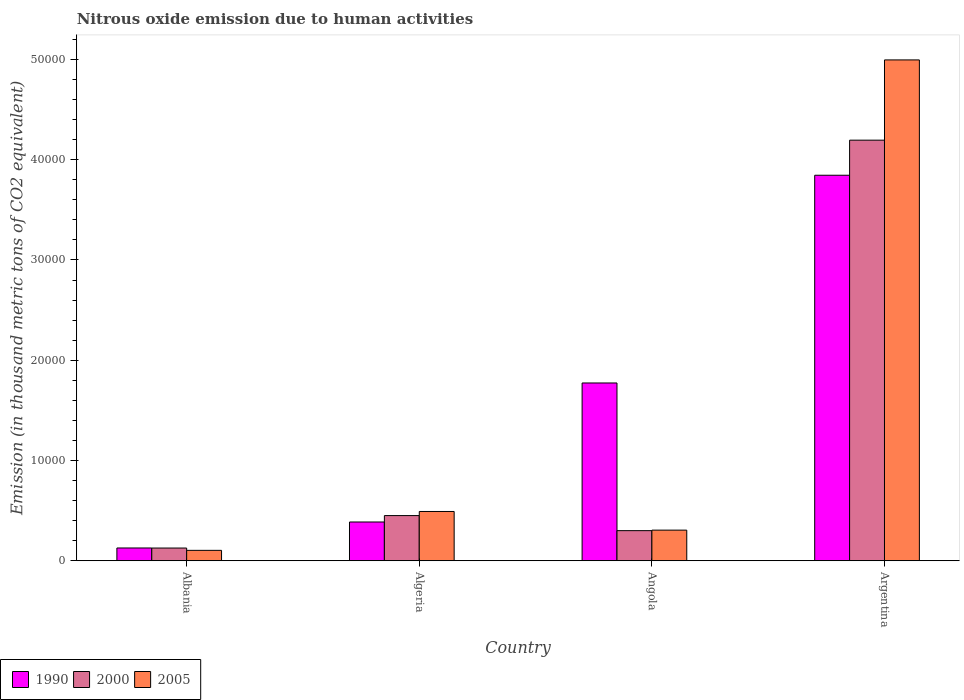How many groups of bars are there?
Your answer should be very brief. 4. What is the label of the 1st group of bars from the left?
Your response must be concise. Albania. In how many cases, is the number of bars for a given country not equal to the number of legend labels?
Make the answer very short. 0. What is the amount of nitrous oxide emitted in 2005 in Algeria?
Make the answer very short. 4917. Across all countries, what is the maximum amount of nitrous oxide emitted in 1990?
Your answer should be compact. 3.85e+04. Across all countries, what is the minimum amount of nitrous oxide emitted in 2005?
Ensure brevity in your answer.  1039.6. In which country was the amount of nitrous oxide emitted in 2005 minimum?
Give a very brief answer. Albania. What is the total amount of nitrous oxide emitted in 1990 in the graph?
Offer a terse response. 6.13e+04. What is the difference between the amount of nitrous oxide emitted in 2005 in Algeria and that in Argentina?
Your response must be concise. -4.50e+04. What is the difference between the amount of nitrous oxide emitted in 2005 in Argentina and the amount of nitrous oxide emitted in 1990 in Angola?
Provide a short and direct response. 3.22e+04. What is the average amount of nitrous oxide emitted in 2005 per country?
Your answer should be very brief. 1.47e+04. What is the difference between the amount of nitrous oxide emitted of/in 2005 and amount of nitrous oxide emitted of/in 2000 in Algeria?
Offer a terse response. 409.9. In how many countries, is the amount of nitrous oxide emitted in 2005 greater than 42000 thousand metric tons?
Make the answer very short. 1. What is the ratio of the amount of nitrous oxide emitted in 1990 in Angola to that in Argentina?
Offer a terse response. 0.46. What is the difference between the highest and the second highest amount of nitrous oxide emitted in 1990?
Offer a very short reply. -3.46e+04. What is the difference between the highest and the lowest amount of nitrous oxide emitted in 2005?
Your response must be concise. 4.89e+04. In how many countries, is the amount of nitrous oxide emitted in 2000 greater than the average amount of nitrous oxide emitted in 2000 taken over all countries?
Ensure brevity in your answer.  1. What does the 2nd bar from the left in Argentina represents?
Provide a short and direct response. 2000. What does the 1st bar from the right in Albania represents?
Your response must be concise. 2005. Is it the case that in every country, the sum of the amount of nitrous oxide emitted in 2005 and amount of nitrous oxide emitted in 1990 is greater than the amount of nitrous oxide emitted in 2000?
Your response must be concise. Yes. Are the values on the major ticks of Y-axis written in scientific E-notation?
Offer a terse response. No. Does the graph contain any zero values?
Make the answer very short. No. What is the title of the graph?
Your response must be concise. Nitrous oxide emission due to human activities. What is the label or title of the Y-axis?
Provide a short and direct response. Emission (in thousand metric tons of CO2 equivalent). What is the Emission (in thousand metric tons of CO2 equivalent) of 1990 in Albania?
Provide a short and direct response. 1276.4. What is the Emission (in thousand metric tons of CO2 equivalent) in 2000 in Albania?
Your answer should be very brief. 1270.7. What is the Emission (in thousand metric tons of CO2 equivalent) of 2005 in Albania?
Your answer should be compact. 1039.6. What is the Emission (in thousand metric tons of CO2 equivalent) of 1990 in Algeria?
Offer a terse response. 3867.6. What is the Emission (in thousand metric tons of CO2 equivalent) of 2000 in Algeria?
Your answer should be compact. 4507.1. What is the Emission (in thousand metric tons of CO2 equivalent) in 2005 in Algeria?
Give a very brief answer. 4917. What is the Emission (in thousand metric tons of CO2 equivalent) in 1990 in Angola?
Your answer should be compact. 1.77e+04. What is the Emission (in thousand metric tons of CO2 equivalent) of 2000 in Angola?
Keep it short and to the point. 3005.3. What is the Emission (in thousand metric tons of CO2 equivalent) in 2005 in Angola?
Your response must be concise. 3056.7. What is the Emission (in thousand metric tons of CO2 equivalent) in 1990 in Argentina?
Give a very brief answer. 3.85e+04. What is the Emission (in thousand metric tons of CO2 equivalent) in 2000 in Argentina?
Keep it short and to the point. 4.20e+04. What is the Emission (in thousand metric tons of CO2 equivalent) of 2005 in Argentina?
Your response must be concise. 5.00e+04. Across all countries, what is the maximum Emission (in thousand metric tons of CO2 equivalent) in 1990?
Provide a short and direct response. 3.85e+04. Across all countries, what is the maximum Emission (in thousand metric tons of CO2 equivalent) of 2000?
Ensure brevity in your answer.  4.20e+04. Across all countries, what is the maximum Emission (in thousand metric tons of CO2 equivalent) in 2005?
Give a very brief answer. 5.00e+04. Across all countries, what is the minimum Emission (in thousand metric tons of CO2 equivalent) of 1990?
Ensure brevity in your answer.  1276.4. Across all countries, what is the minimum Emission (in thousand metric tons of CO2 equivalent) in 2000?
Offer a terse response. 1270.7. Across all countries, what is the minimum Emission (in thousand metric tons of CO2 equivalent) in 2005?
Offer a terse response. 1039.6. What is the total Emission (in thousand metric tons of CO2 equivalent) of 1990 in the graph?
Ensure brevity in your answer.  6.13e+04. What is the total Emission (in thousand metric tons of CO2 equivalent) in 2000 in the graph?
Your answer should be very brief. 5.07e+04. What is the total Emission (in thousand metric tons of CO2 equivalent) of 2005 in the graph?
Ensure brevity in your answer.  5.90e+04. What is the difference between the Emission (in thousand metric tons of CO2 equivalent) in 1990 in Albania and that in Algeria?
Your answer should be compact. -2591.2. What is the difference between the Emission (in thousand metric tons of CO2 equivalent) of 2000 in Albania and that in Algeria?
Make the answer very short. -3236.4. What is the difference between the Emission (in thousand metric tons of CO2 equivalent) in 2005 in Albania and that in Algeria?
Your answer should be compact. -3877.4. What is the difference between the Emission (in thousand metric tons of CO2 equivalent) in 1990 in Albania and that in Angola?
Offer a very short reply. -1.65e+04. What is the difference between the Emission (in thousand metric tons of CO2 equivalent) of 2000 in Albania and that in Angola?
Offer a very short reply. -1734.6. What is the difference between the Emission (in thousand metric tons of CO2 equivalent) in 2005 in Albania and that in Angola?
Provide a short and direct response. -2017.1. What is the difference between the Emission (in thousand metric tons of CO2 equivalent) in 1990 in Albania and that in Argentina?
Make the answer very short. -3.72e+04. What is the difference between the Emission (in thousand metric tons of CO2 equivalent) of 2000 in Albania and that in Argentina?
Provide a succinct answer. -4.07e+04. What is the difference between the Emission (in thousand metric tons of CO2 equivalent) in 2005 in Albania and that in Argentina?
Offer a terse response. -4.89e+04. What is the difference between the Emission (in thousand metric tons of CO2 equivalent) in 1990 in Algeria and that in Angola?
Offer a terse response. -1.39e+04. What is the difference between the Emission (in thousand metric tons of CO2 equivalent) in 2000 in Algeria and that in Angola?
Your answer should be very brief. 1501.8. What is the difference between the Emission (in thousand metric tons of CO2 equivalent) in 2005 in Algeria and that in Angola?
Your answer should be very brief. 1860.3. What is the difference between the Emission (in thousand metric tons of CO2 equivalent) of 1990 in Algeria and that in Argentina?
Your answer should be very brief. -3.46e+04. What is the difference between the Emission (in thousand metric tons of CO2 equivalent) of 2000 in Algeria and that in Argentina?
Give a very brief answer. -3.74e+04. What is the difference between the Emission (in thousand metric tons of CO2 equivalent) of 2005 in Algeria and that in Argentina?
Your response must be concise. -4.50e+04. What is the difference between the Emission (in thousand metric tons of CO2 equivalent) of 1990 in Angola and that in Argentina?
Your answer should be compact. -2.07e+04. What is the difference between the Emission (in thousand metric tons of CO2 equivalent) in 2000 in Angola and that in Argentina?
Your response must be concise. -3.89e+04. What is the difference between the Emission (in thousand metric tons of CO2 equivalent) in 2005 in Angola and that in Argentina?
Your answer should be very brief. -4.69e+04. What is the difference between the Emission (in thousand metric tons of CO2 equivalent) in 1990 in Albania and the Emission (in thousand metric tons of CO2 equivalent) in 2000 in Algeria?
Provide a succinct answer. -3230.7. What is the difference between the Emission (in thousand metric tons of CO2 equivalent) of 1990 in Albania and the Emission (in thousand metric tons of CO2 equivalent) of 2005 in Algeria?
Your answer should be compact. -3640.6. What is the difference between the Emission (in thousand metric tons of CO2 equivalent) of 2000 in Albania and the Emission (in thousand metric tons of CO2 equivalent) of 2005 in Algeria?
Make the answer very short. -3646.3. What is the difference between the Emission (in thousand metric tons of CO2 equivalent) in 1990 in Albania and the Emission (in thousand metric tons of CO2 equivalent) in 2000 in Angola?
Your response must be concise. -1728.9. What is the difference between the Emission (in thousand metric tons of CO2 equivalent) of 1990 in Albania and the Emission (in thousand metric tons of CO2 equivalent) of 2005 in Angola?
Ensure brevity in your answer.  -1780.3. What is the difference between the Emission (in thousand metric tons of CO2 equivalent) in 2000 in Albania and the Emission (in thousand metric tons of CO2 equivalent) in 2005 in Angola?
Offer a very short reply. -1786. What is the difference between the Emission (in thousand metric tons of CO2 equivalent) of 1990 in Albania and the Emission (in thousand metric tons of CO2 equivalent) of 2000 in Argentina?
Your answer should be very brief. -4.07e+04. What is the difference between the Emission (in thousand metric tons of CO2 equivalent) of 1990 in Albania and the Emission (in thousand metric tons of CO2 equivalent) of 2005 in Argentina?
Ensure brevity in your answer.  -4.87e+04. What is the difference between the Emission (in thousand metric tons of CO2 equivalent) in 2000 in Albania and the Emission (in thousand metric tons of CO2 equivalent) in 2005 in Argentina?
Offer a very short reply. -4.87e+04. What is the difference between the Emission (in thousand metric tons of CO2 equivalent) in 1990 in Algeria and the Emission (in thousand metric tons of CO2 equivalent) in 2000 in Angola?
Make the answer very short. 862.3. What is the difference between the Emission (in thousand metric tons of CO2 equivalent) of 1990 in Algeria and the Emission (in thousand metric tons of CO2 equivalent) of 2005 in Angola?
Your answer should be compact. 810.9. What is the difference between the Emission (in thousand metric tons of CO2 equivalent) of 2000 in Algeria and the Emission (in thousand metric tons of CO2 equivalent) of 2005 in Angola?
Give a very brief answer. 1450.4. What is the difference between the Emission (in thousand metric tons of CO2 equivalent) of 1990 in Algeria and the Emission (in thousand metric tons of CO2 equivalent) of 2000 in Argentina?
Provide a succinct answer. -3.81e+04. What is the difference between the Emission (in thousand metric tons of CO2 equivalent) in 1990 in Algeria and the Emission (in thousand metric tons of CO2 equivalent) in 2005 in Argentina?
Offer a terse response. -4.61e+04. What is the difference between the Emission (in thousand metric tons of CO2 equivalent) in 2000 in Algeria and the Emission (in thousand metric tons of CO2 equivalent) in 2005 in Argentina?
Provide a succinct answer. -4.54e+04. What is the difference between the Emission (in thousand metric tons of CO2 equivalent) of 1990 in Angola and the Emission (in thousand metric tons of CO2 equivalent) of 2000 in Argentina?
Your answer should be very brief. -2.42e+04. What is the difference between the Emission (in thousand metric tons of CO2 equivalent) in 1990 in Angola and the Emission (in thousand metric tons of CO2 equivalent) in 2005 in Argentina?
Your answer should be very brief. -3.22e+04. What is the difference between the Emission (in thousand metric tons of CO2 equivalent) in 2000 in Angola and the Emission (in thousand metric tons of CO2 equivalent) in 2005 in Argentina?
Your answer should be compact. -4.70e+04. What is the average Emission (in thousand metric tons of CO2 equivalent) in 1990 per country?
Provide a short and direct response. 1.53e+04. What is the average Emission (in thousand metric tons of CO2 equivalent) in 2000 per country?
Your response must be concise. 1.27e+04. What is the average Emission (in thousand metric tons of CO2 equivalent) of 2005 per country?
Your answer should be compact. 1.47e+04. What is the difference between the Emission (in thousand metric tons of CO2 equivalent) in 1990 and Emission (in thousand metric tons of CO2 equivalent) in 2000 in Albania?
Your answer should be very brief. 5.7. What is the difference between the Emission (in thousand metric tons of CO2 equivalent) of 1990 and Emission (in thousand metric tons of CO2 equivalent) of 2005 in Albania?
Provide a succinct answer. 236.8. What is the difference between the Emission (in thousand metric tons of CO2 equivalent) of 2000 and Emission (in thousand metric tons of CO2 equivalent) of 2005 in Albania?
Keep it short and to the point. 231.1. What is the difference between the Emission (in thousand metric tons of CO2 equivalent) in 1990 and Emission (in thousand metric tons of CO2 equivalent) in 2000 in Algeria?
Your answer should be compact. -639.5. What is the difference between the Emission (in thousand metric tons of CO2 equivalent) in 1990 and Emission (in thousand metric tons of CO2 equivalent) in 2005 in Algeria?
Offer a very short reply. -1049.4. What is the difference between the Emission (in thousand metric tons of CO2 equivalent) in 2000 and Emission (in thousand metric tons of CO2 equivalent) in 2005 in Algeria?
Offer a terse response. -409.9. What is the difference between the Emission (in thousand metric tons of CO2 equivalent) in 1990 and Emission (in thousand metric tons of CO2 equivalent) in 2000 in Angola?
Make the answer very short. 1.47e+04. What is the difference between the Emission (in thousand metric tons of CO2 equivalent) in 1990 and Emission (in thousand metric tons of CO2 equivalent) in 2005 in Angola?
Your response must be concise. 1.47e+04. What is the difference between the Emission (in thousand metric tons of CO2 equivalent) in 2000 and Emission (in thousand metric tons of CO2 equivalent) in 2005 in Angola?
Give a very brief answer. -51.4. What is the difference between the Emission (in thousand metric tons of CO2 equivalent) of 1990 and Emission (in thousand metric tons of CO2 equivalent) of 2000 in Argentina?
Your answer should be very brief. -3498.7. What is the difference between the Emission (in thousand metric tons of CO2 equivalent) of 1990 and Emission (in thousand metric tons of CO2 equivalent) of 2005 in Argentina?
Your answer should be very brief. -1.15e+04. What is the difference between the Emission (in thousand metric tons of CO2 equivalent) of 2000 and Emission (in thousand metric tons of CO2 equivalent) of 2005 in Argentina?
Ensure brevity in your answer.  -8004.7. What is the ratio of the Emission (in thousand metric tons of CO2 equivalent) in 1990 in Albania to that in Algeria?
Provide a succinct answer. 0.33. What is the ratio of the Emission (in thousand metric tons of CO2 equivalent) of 2000 in Albania to that in Algeria?
Make the answer very short. 0.28. What is the ratio of the Emission (in thousand metric tons of CO2 equivalent) of 2005 in Albania to that in Algeria?
Provide a short and direct response. 0.21. What is the ratio of the Emission (in thousand metric tons of CO2 equivalent) in 1990 in Albania to that in Angola?
Ensure brevity in your answer.  0.07. What is the ratio of the Emission (in thousand metric tons of CO2 equivalent) of 2000 in Albania to that in Angola?
Provide a succinct answer. 0.42. What is the ratio of the Emission (in thousand metric tons of CO2 equivalent) of 2005 in Albania to that in Angola?
Your answer should be very brief. 0.34. What is the ratio of the Emission (in thousand metric tons of CO2 equivalent) of 1990 in Albania to that in Argentina?
Ensure brevity in your answer.  0.03. What is the ratio of the Emission (in thousand metric tons of CO2 equivalent) of 2000 in Albania to that in Argentina?
Your answer should be compact. 0.03. What is the ratio of the Emission (in thousand metric tons of CO2 equivalent) of 2005 in Albania to that in Argentina?
Your answer should be very brief. 0.02. What is the ratio of the Emission (in thousand metric tons of CO2 equivalent) in 1990 in Algeria to that in Angola?
Your answer should be compact. 0.22. What is the ratio of the Emission (in thousand metric tons of CO2 equivalent) in 2000 in Algeria to that in Angola?
Make the answer very short. 1.5. What is the ratio of the Emission (in thousand metric tons of CO2 equivalent) in 2005 in Algeria to that in Angola?
Ensure brevity in your answer.  1.61. What is the ratio of the Emission (in thousand metric tons of CO2 equivalent) of 1990 in Algeria to that in Argentina?
Keep it short and to the point. 0.1. What is the ratio of the Emission (in thousand metric tons of CO2 equivalent) of 2000 in Algeria to that in Argentina?
Your answer should be compact. 0.11. What is the ratio of the Emission (in thousand metric tons of CO2 equivalent) of 2005 in Algeria to that in Argentina?
Your response must be concise. 0.1. What is the ratio of the Emission (in thousand metric tons of CO2 equivalent) in 1990 in Angola to that in Argentina?
Provide a succinct answer. 0.46. What is the ratio of the Emission (in thousand metric tons of CO2 equivalent) of 2000 in Angola to that in Argentina?
Your answer should be compact. 0.07. What is the ratio of the Emission (in thousand metric tons of CO2 equivalent) in 2005 in Angola to that in Argentina?
Ensure brevity in your answer.  0.06. What is the difference between the highest and the second highest Emission (in thousand metric tons of CO2 equivalent) of 1990?
Offer a very short reply. 2.07e+04. What is the difference between the highest and the second highest Emission (in thousand metric tons of CO2 equivalent) of 2000?
Keep it short and to the point. 3.74e+04. What is the difference between the highest and the second highest Emission (in thousand metric tons of CO2 equivalent) in 2005?
Ensure brevity in your answer.  4.50e+04. What is the difference between the highest and the lowest Emission (in thousand metric tons of CO2 equivalent) in 1990?
Provide a short and direct response. 3.72e+04. What is the difference between the highest and the lowest Emission (in thousand metric tons of CO2 equivalent) of 2000?
Keep it short and to the point. 4.07e+04. What is the difference between the highest and the lowest Emission (in thousand metric tons of CO2 equivalent) in 2005?
Offer a very short reply. 4.89e+04. 